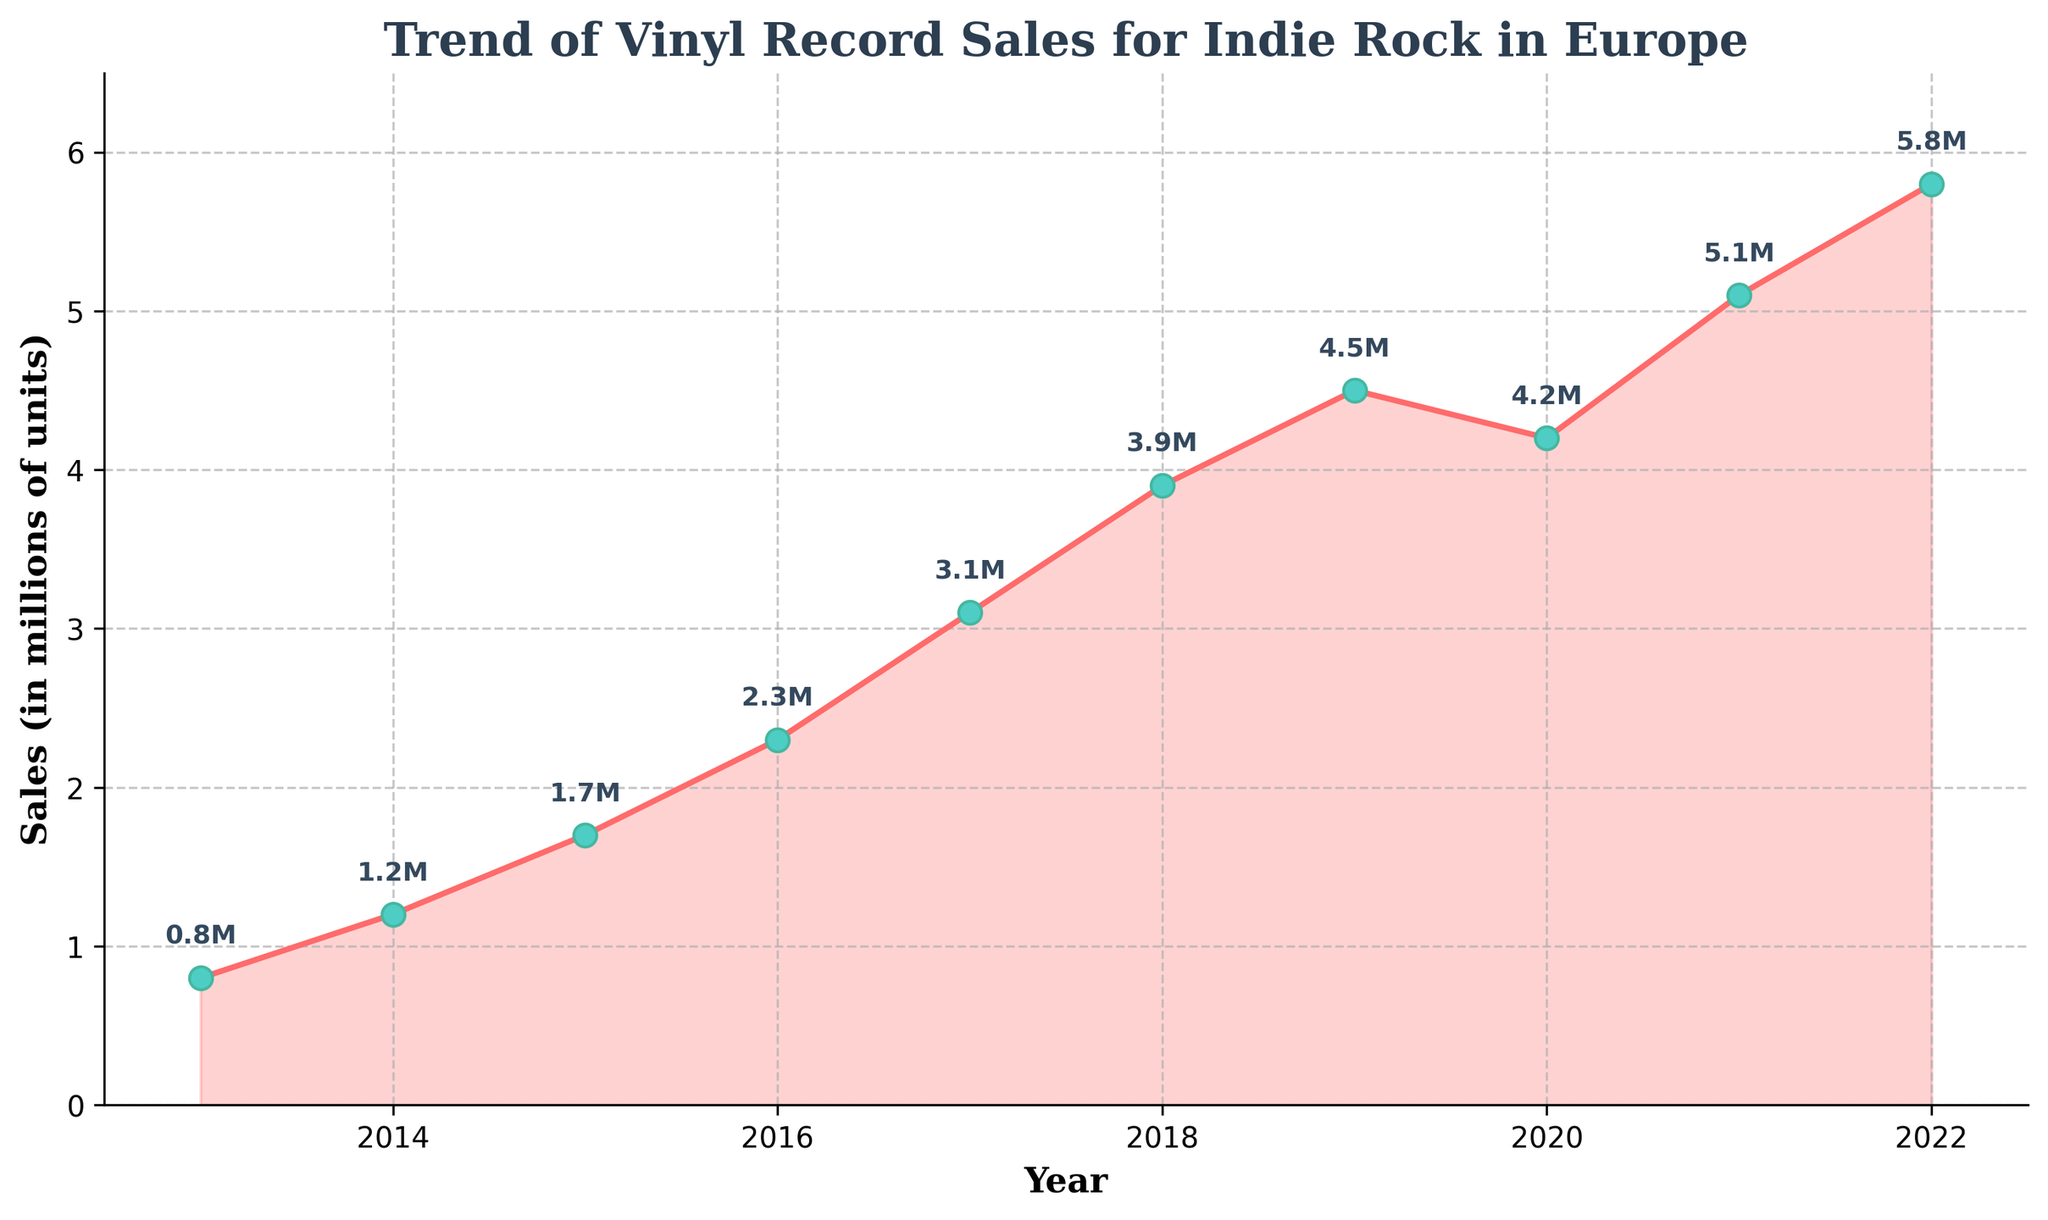What's the overall trend of vinyl record sales for indie rock in Europe over the last decade? The trend is represented by the plotted line connecting the data points from 2013 to 2022, showing an overall increase in sales from 0.8 million to 5.8 million units, despite a slight dip in 2020.
Answer: Increasing Which year had the highest vinyl record sales for indie rock? The plotted line has data points annotated with sales values for each year from 2013 to 2022. The highest value is 5.8 million in 2022.
Answer: 2022 Compare the sales in 2014 and 2018. Which year had greater sales and by how much? Identify the sales values from the labeled points: 1.2 million in 2014 and 3.9 million in 2018. The difference is 3.9 - 1.2 = 2.7 million units, with 2018 being higher.
Answer: 2018 by 2.7 million units What was the sales growth between 2013 and 2017? Compare sales values for these years: 0.8 million in 2013 and 3.1 million in 2017. The growth is calculated: 3.1 - 0.8 = 2.3 million units.
Answer: 2.3 million units Which years showed a decline in sales compared to the previous year? Watch the plotted line descending at any point; the only decline is from 2019 to 2020, where sales dropped from 4.5 million to 4.2 million.
Answer: 2020 Calculate the average annual sales growth from 2013 to 2022. Find the total growth over the period: 5.8 million (2022) - 0.8 million (2013) = 5 million units. Divide this by the number of years (2022-2013 = 9 years): 5 / 9 = 0.56 million units per year.
Answer: 0.56 million units per year During which period between consecutive years did the sales increase the most? Observe the differences between consecutive years: the largest increment is between 2017 (3.1 million) and 2018 (3.9 million), showing an increase of 0.8 million units.
Answer: 2017-2018 What was the average sales value for indie rock vinyl records from 2013 to 2022? Sum all sales values and divide by the number of years: (0.8 + 1.2 + 1.7 + 2.3 + 3.1 + 3.9 + 4.5 + 4.2 + 5.1 + 5.8) / 10 = 3.16 million units.
Answer: 3.16 million units Describe the visual elements used for the markers and the line in the plot. The markers are circular with a green face and teal edges, and the line connecting them is solid with a red color. The markers are also highlighted with annotated sale values.
Answer: Circular green and teal markers, solid red line What sales value was annotated on the plot for the year 2015? Read the annotated value directly above the 2015 marker, which is labeled as 1.7 million units.
Answer: 1.7 million units 